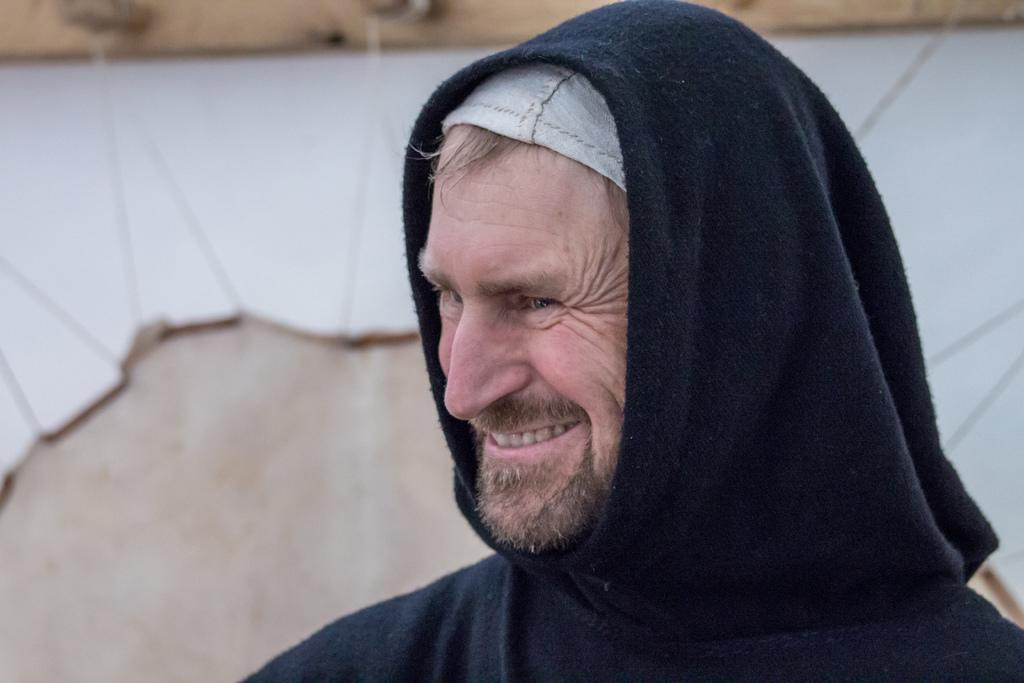What is the main subject of the image? There is a person in the image. What is the person doing in the image? The person is smiling. What is the person wearing in the image? The person is wearing a black and white color dress. What colors are present in the background of the image? The background of the image is in cream and white color. How many geese are present in the image? There are no geese present in the image. What type of lace is used in the person's dress? The provided facts do not mention any lace in the person's dress. 